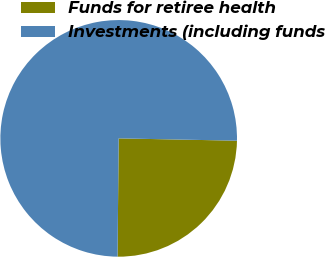Convert chart to OTSL. <chart><loc_0><loc_0><loc_500><loc_500><pie_chart><fcel>Funds for retiree health<fcel>Investments (including funds<nl><fcel>24.84%<fcel>75.16%<nl></chart> 